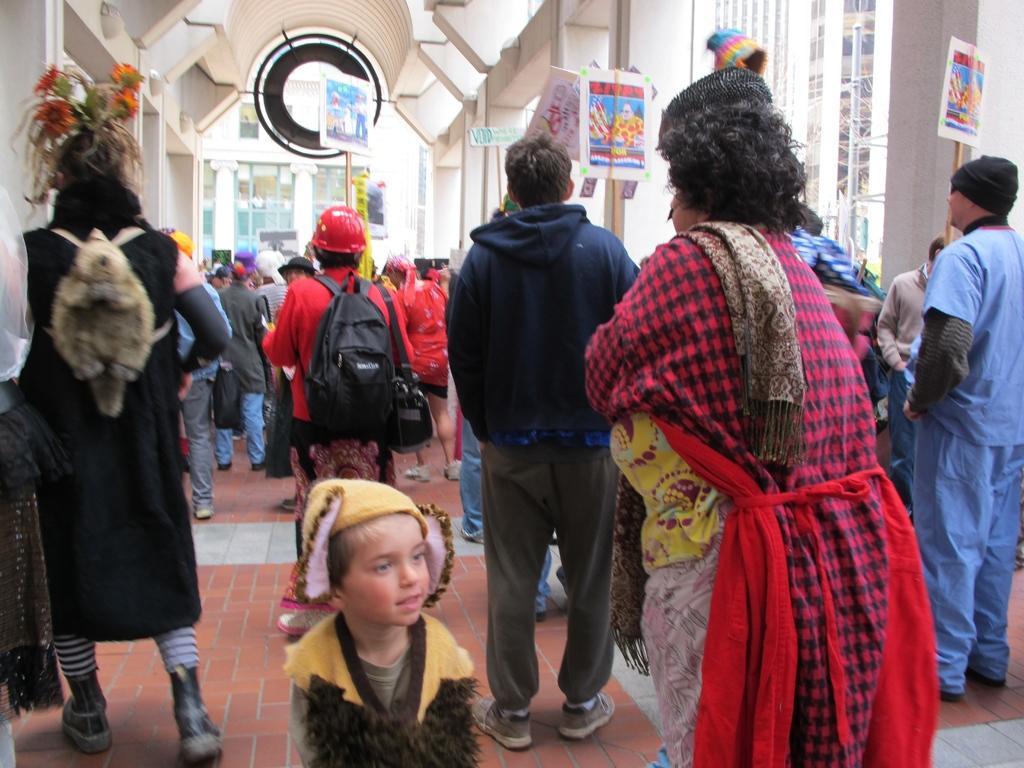Can you describe this image briefly? In this picture I see number of people in front who are on the path and I see few of them are holding boards in their hands and in the background I see the buildings. 